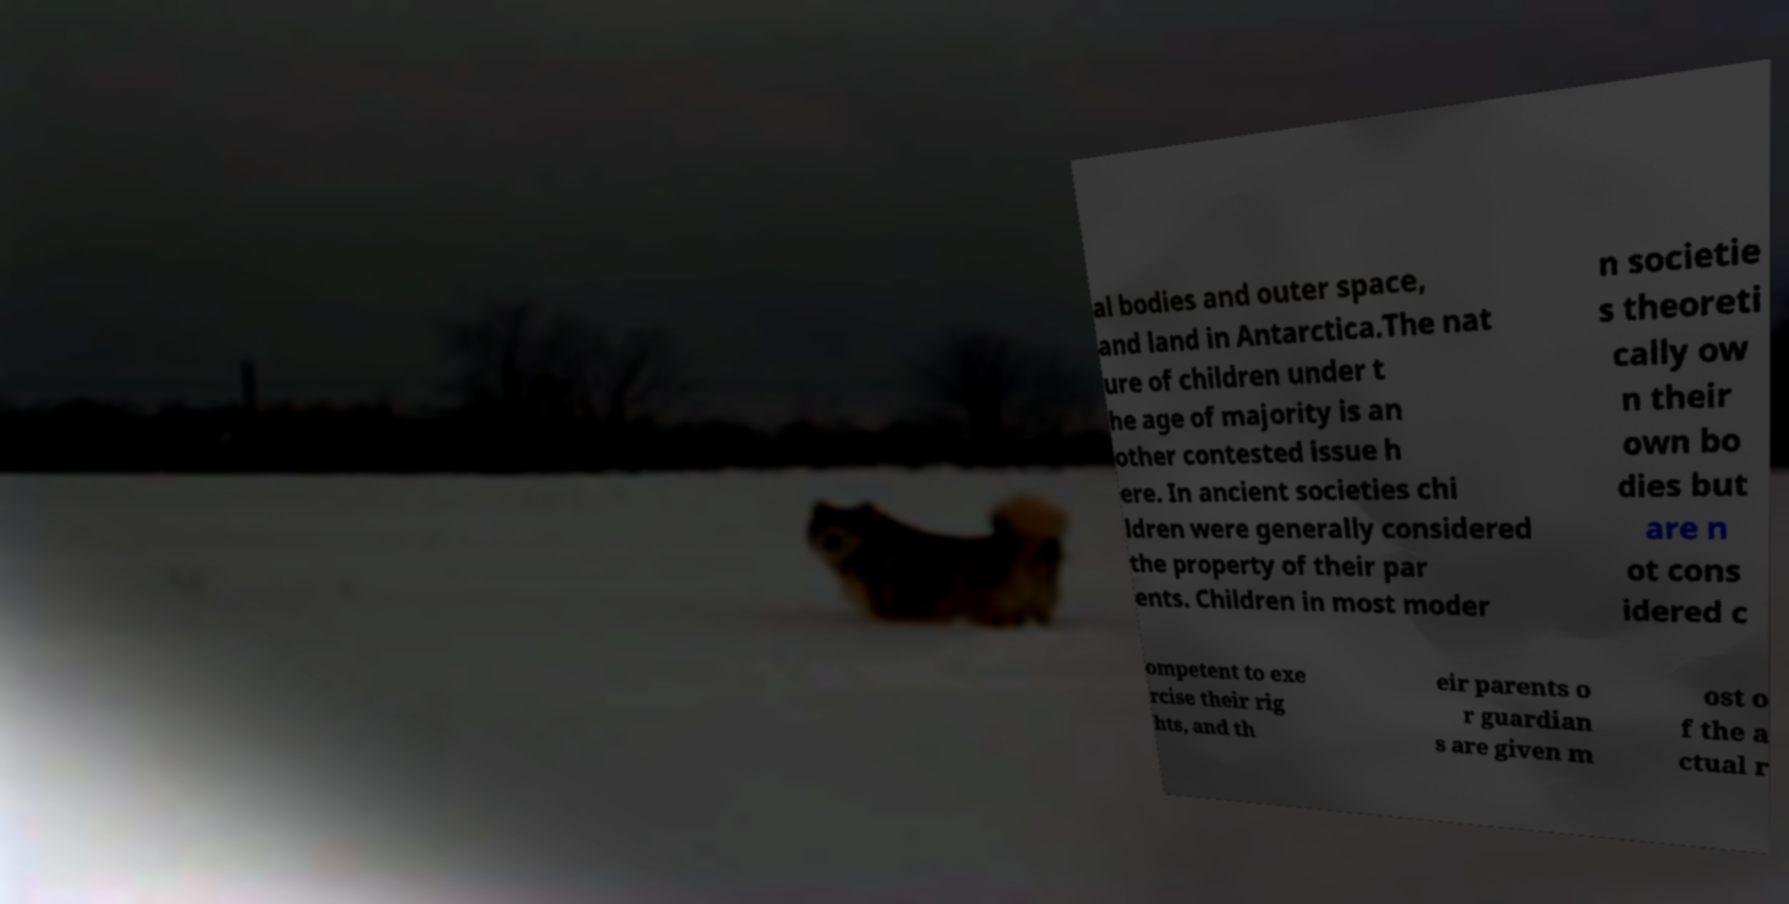For documentation purposes, I need the text within this image transcribed. Could you provide that? al bodies and outer space, and land in Antarctica.The nat ure of children under t he age of majority is an other contested issue h ere. In ancient societies chi ldren were generally considered the property of their par ents. Children in most moder n societie s theoreti cally ow n their own bo dies but are n ot cons idered c ompetent to exe rcise their rig hts, and th eir parents o r guardian s are given m ost o f the a ctual r 